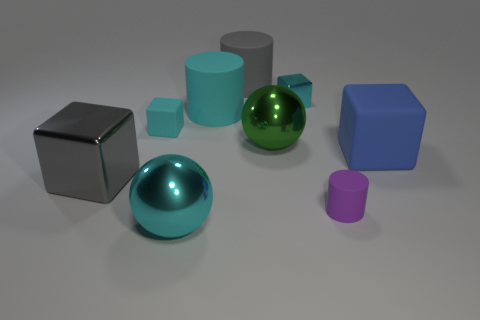Which object stands out the most and why? The green, glossy sphere stands out the most due to its vibrant color that contrasts sharply with the muted tones of the other objects and the reflective surface that catches the light differently compared to the other objects. 